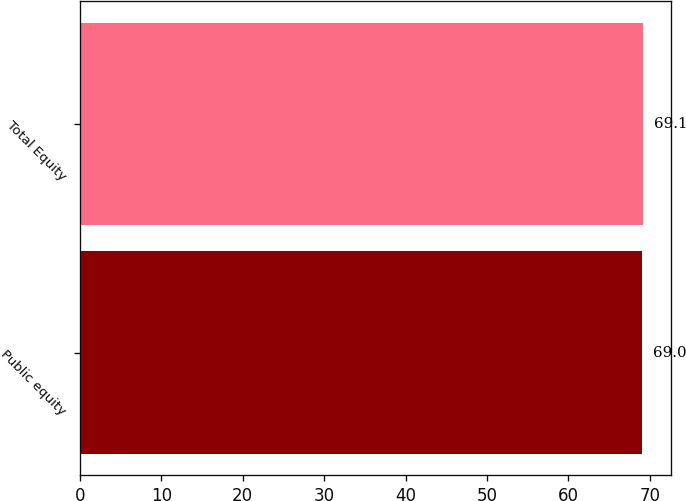Convert chart to OTSL. <chart><loc_0><loc_0><loc_500><loc_500><bar_chart><fcel>Public equity<fcel>Total Equity<nl><fcel>69<fcel>69.1<nl></chart> 